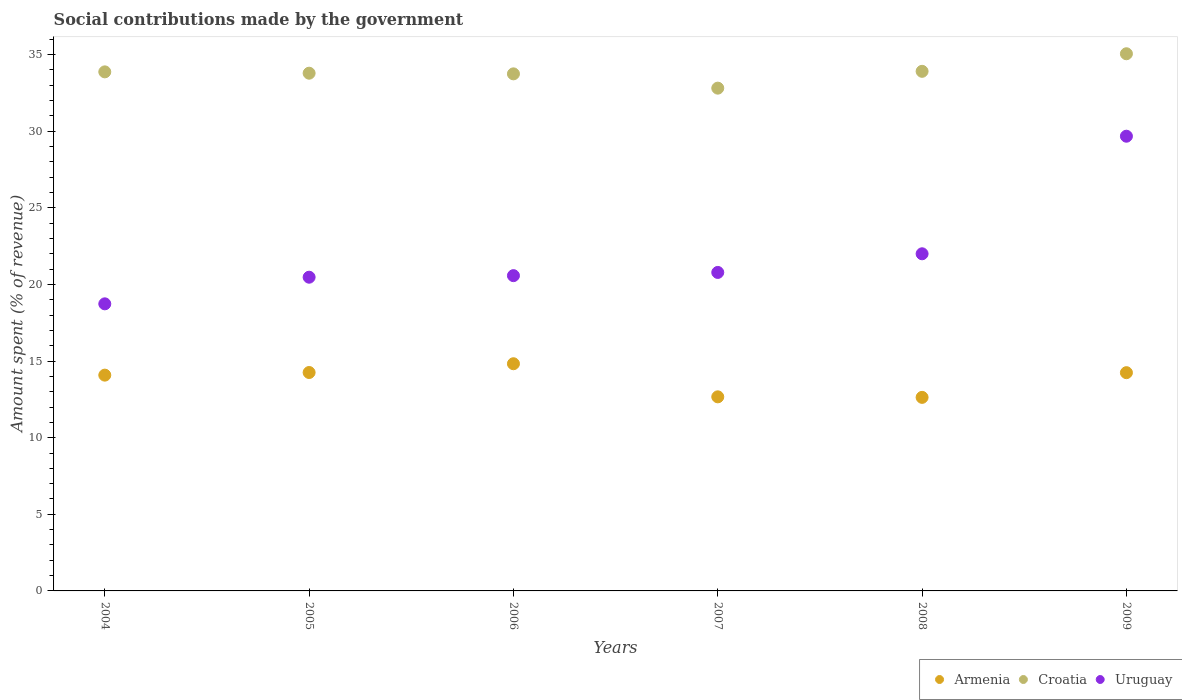How many different coloured dotlines are there?
Provide a succinct answer. 3. Is the number of dotlines equal to the number of legend labels?
Offer a terse response. Yes. What is the amount spent (in %) on social contributions in Armenia in 2007?
Keep it short and to the point. 12.67. Across all years, what is the maximum amount spent (in %) on social contributions in Croatia?
Provide a short and direct response. 35.06. Across all years, what is the minimum amount spent (in %) on social contributions in Croatia?
Your answer should be very brief. 32.81. In which year was the amount spent (in %) on social contributions in Armenia maximum?
Your answer should be compact. 2006. What is the total amount spent (in %) on social contributions in Armenia in the graph?
Make the answer very short. 82.7. What is the difference between the amount spent (in %) on social contributions in Croatia in 2004 and that in 2005?
Your response must be concise. 0.09. What is the difference between the amount spent (in %) on social contributions in Uruguay in 2004 and the amount spent (in %) on social contributions in Armenia in 2009?
Your answer should be compact. 4.49. What is the average amount spent (in %) on social contributions in Croatia per year?
Your response must be concise. 33.86. In the year 2004, what is the difference between the amount spent (in %) on social contributions in Armenia and amount spent (in %) on social contributions in Croatia?
Your answer should be compact. -19.79. What is the ratio of the amount spent (in %) on social contributions in Croatia in 2005 to that in 2008?
Keep it short and to the point. 1. What is the difference between the highest and the second highest amount spent (in %) on social contributions in Armenia?
Your response must be concise. 0.57. What is the difference between the highest and the lowest amount spent (in %) on social contributions in Croatia?
Make the answer very short. 2.24. In how many years, is the amount spent (in %) on social contributions in Croatia greater than the average amount spent (in %) on social contributions in Croatia taken over all years?
Provide a succinct answer. 3. Does the amount spent (in %) on social contributions in Uruguay monotonically increase over the years?
Provide a succinct answer. Yes. Is the amount spent (in %) on social contributions in Armenia strictly less than the amount spent (in %) on social contributions in Croatia over the years?
Ensure brevity in your answer.  Yes. How many dotlines are there?
Give a very brief answer. 3. Are the values on the major ticks of Y-axis written in scientific E-notation?
Provide a succinct answer. No. Does the graph contain any zero values?
Provide a short and direct response. No. Where does the legend appear in the graph?
Provide a short and direct response. Bottom right. How are the legend labels stacked?
Ensure brevity in your answer.  Horizontal. What is the title of the graph?
Provide a short and direct response. Social contributions made by the government. Does "Morocco" appear as one of the legend labels in the graph?
Your answer should be very brief. No. What is the label or title of the X-axis?
Give a very brief answer. Years. What is the label or title of the Y-axis?
Provide a short and direct response. Amount spent (% of revenue). What is the Amount spent (% of revenue) in Armenia in 2004?
Your response must be concise. 14.08. What is the Amount spent (% of revenue) in Croatia in 2004?
Keep it short and to the point. 33.87. What is the Amount spent (% of revenue) in Uruguay in 2004?
Ensure brevity in your answer.  18.74. What is the Amount spent (% of revenue) of Armenia in 2005?
Make the answer very short. 14.25. What is the Amount spent (% of revenue) of Croatia in 2005?
Provide a short and direct response. 33.79. What is the Amount spent (% of revenue) of Uruguay in 2005?
Offer a very short reply. 20.47. What is the Amount spent (% of revenue) in Armenia in 2006?
Offer a terse response. 14.83. What is the Amount spent (% of revenue) of Croatia in 2006?
Provide a short and direct response. 33.74. What is the Amount spent (% of revenue) of Uruguay in 2006?
Keep it short and to the point. 20.58. What is the Amount spent (% of revenue) of Armenia in 2007?
Ensure brevity in your answer.  12.67. What is the Amount spent (% of revenue) of Croatia in 2007?
Ensure brevity in your answer.  32.81. What is the Amount spent (% of revenue) of Uruguay in 2007?
Offer a very short reply. 20.79. What is the Amount spent (% of revenue) in Armenia in 2008?
Your response must be concise. 12.63. What is the Amount spent (% of revenue) in Croatia in 2008?
Offer a terse response. 33.91. What is the Amount spent (% of revenue) in Uruguay in 2008?
Your answer should be very brief. 22. What is the Amount spent (% of revenue) of Armenia in 2009?
Your response must be concise. 14.24. What is the Amount spent (% of revenue) in Croatia in 2009?
Provide a short and direct response. 35.06. What is the Amount spent (% of revenue) in Uruguay in 2009?
Provide a succinct answer. 29.68. Across all years, what is the maximum Amount spent (% of revenue) of Armenia?
Offer a very short reply. 14.83. Across all years, what is the maximum Amount spent (% of revenue) of Croatia?
Provide a short and direct response. 35.06. Across all years, what is the maximum Amount spent (% of revenue) in Uruguay?
Make the answer very short. 29.68. Across all years, what is the minimum Amount spent (% of revenue) of Armenia?
Your answer should be very brief. 12.63. Across all years, what is the minimum Amount spent (% of revenue) of Croatia?
Keep it short and to the point. 32.81. Across all years, what is the minimum Amount spent (% of revenue) in Uruguay?
Provide a succinct answer. 18.74. What is the total Amount spent (% of revenue) of Armenia in the graph?
Provide a short and direct response. 82.7. What is the total Amount spent (% of revenue) of Croatia in the graph?
Give a very brief answer. 203.18. What is the total Amount spent (% of revenue) of Uruguay in the graph?
Offer a terse response. 132.25. What is the difference between the Amount spent (% of revenue) in Armenia in 2004 and that in 2005?
Give a very brief answer. -0.17. What is the difference between the Amount spent (% of revenue) of Croatia in 2004 and that in 2005?
Make the answer very short. 0.09. What is the difference between the Amount spent (% of revenue) in Uruguay in 2004 and that in 2005?
Give a very brief answer. -1.74. What is the difference between the Amount spent (% of revenue) in Armenia in 2004 and that in 2006?
Offer a terse response. -0.74. What is the difference between the Amount spent (% of revenue) of Croatia in 2004 and that in 2006?
Make the answer very short. 0.13. What is the difference between the Amount spent (% of revenue) in Uruguay in 2004 and that in 2006?
Offer a terse response. -1.84. What is the difference between the Amount spent (% of revenue) of Armenia in 2004 and that in 2007?
Make the answer very short. 1.42. What is the difference between the Amount spent (% of revenue) of Croatia in 2004 and that in 2007?
Offer a very short reply. 1.06. What is the difference between the Amount spent (% of revenue) of Uruguay in 2004 and that in 2007?
Offer a terse response. -2.05. What is the difference between the Amount spent (% of revenue) in Armenia in 2004 and that in 2008?
Provide a short and direct response. 1.45. What is the difference between the Amount spent (% of revenue) of Croatia in 2004 and that in 2008?
Offer a very short reply. -0.03. What is the difference between the Amount spent (% of revenue) of Uruguay in 2004 and that in 2008?
Offer a very short reply. -3.27. What is the difference between the Amount spent (% of revenue) in Armenia in 2004 and that in 2009?
Make the answer very short. -0.16. What is the difference between the Amount spent (% of revenue) in Croatia in 2004 and that in 2009?
Your answer should be compact. -1.18. What is the difference between the Amount spent (% of revenue) of Uruguay in 2004 and that in 2009?
Offer a terse response. -10.94. What is the difference between the Amount spent (% of revenue) of Armenia in 2005 and that in 2006?
Your answer should be compact. -0.57. What is the difference between the Amount spent (% of revenue) in Croatia in 2005 and that in 2006?
Provide a short and direct response. 0.04. What is the difference between the Amount spent (% of revenue) in Uruguay in 2005 and that in 2006?
Your answer should be compact. -0.1. What is the difference between the Amount spent (% of revenue) of Armenia in 2005 and that in 2007?
Provide a succinct answer. 1.59. What is the difference between the Amount spent (% of revenue) of Croatia in 2005 and that in 2007?
Make the answer very short. 0.98. What is the difference between the Amount spent (% of revenue) of Uruguay in 2005 and that in 2007?
Keep it short and to the point. -0.31. What is the difference between the Amount spent (% of revenue) of Armenia in 2005 and that in 2008?
Provide a short and direct response. 1.62. What is the difference between the Amount spent (% of revenue) in Croatia in 2005 and that in 2008?
Your response must be concise. -0.12. What is the difference between the Amount spent (% of revenue) in Uruguay in 2005 and that in 2008?
Your response must be concise. -1.53. What is the difference between the Amount spent (% of revenue) of Armenia in 2005 and that in 2009?
Your answer should be compact. 0.01. What is the difference between the Amount spent (% of revenue) in Croatia in 2005 and that in 2009?
Keep it short and to the point. -1.27. What is the difference between the Amount spent (% of revenue) of Uruguay in 2005 and that in 2009?
Your answer should be compact. -9.2. What is the difference between the Amount spent (% of revenue) of Armenia in 2006 and that in 2007?
Your response must be concise. 2.16. What is the difference between the Amount spent (% of revenue) in Croatia in 2006 and that in 2007?
Offer a very short reply. 0.93. What is the difference between the Amount spent (% of revenue) of Uruguay in 2006 and that in 2007?
Your answer should be very brief. -0.21. What is the difference between the Amount spent (% of revenue) in Armenia in 2006 and that in 2008?
Give a very brief answer. 2.19. What is the difference between the Amount spent (% of revenue) of Croatia in 2006 and that in 2008?
Provide a short and direct response. -0.17. What is the difference between the Amount spent (% of revenue) of Uruguay in 2006 and that in 2008?
Your response must be concise. -1.43. What is the difference between the Amount spent (% of revenue) of Armenia in 2006 and that in 2009?
Offer a very short reply. 0.58. What is the difference between the Amount spent (% of revenue) of Croatia in 2006 and that in 2009?
Offer a terse response. -1.31. What is the difference between the Amount spent (% of revenue) of Armenia in 2007 and that in 2008?
Provide a short and direct response. 0.04. What is the difference between the Amount spent (% of revenue) of Croatia in 2007 and that in 2008?
Make the answer very short. -1.1. What is the difference between the Amount spent (% of revenue) in Uruguay in 2007 and that in 2008?
Provide a succinct answer. -1.22. What is the difference between the Amount spent (% of revenue) of Armenia in 2007 and that in 2009?
Offer a very short reply. -1.58. What is the difference between the Amount spent (% of revenue) of Croatia in 2007 and that in 2009?
Your response must be concise. -2.24. What is the difference between the Amount spent (% of revenue) of Uruguay in 2007 and that in 2009?
Ensure brevity in your answer.  -8.89. What is the difference between the Amount spent (% of revenue) in Armenia in 2008 and that in 2009?
Make the answer very short. -1.61. What is the difference between the Amount spent (% of revenue) in Croatia in 2008 and that in 2009?
Make the answer very short. -1.15. What is the difference between the Amount spent (% of revenue) of Uruguay in 2008 and that in 2009?
Provide a short and direct response. -7.67. What is the difference between the Amount spent (% of revenue) of Armenia in 2004 and the Amount spent (% of revenue) of Croatia in 2005?
Provide a short and direct response. -19.7. What is the difference between the Amount spent (% of revenue) in Armenia in 2004 and the Amount spent (% of revenue) in Uruguay in 2005?
Keep it short and to the point. -6.39. What is the difference between the Amount spent (% of revenue) of Croatia in 2004 and the Amount spent (% of revenue) of Uruguay in 2005?
Your answer should be very brief. 13.4. What is the difference between the Amount spent (% of revenue) of Armenia in 2004 and the Amount spent (% of revenue) of Croatia in 2006?
Provide a short and direct response. -19.66. What is the difference between the Amount spent (% of revenue) of Armenia in 2004 and the Amount spent (% of revenue) of Uruguay in 2006?
Offer a very short reply. -6.49. What is the difference between the Amount spent (% of revenue) in Croatia in 2004 and the Amount spent (% of revenue) in Uruguay in 2006?
Offer a very short reply. 13.3. What is the difference between the Amount spent (% of revenue) in Armenia in 2004 and the Amount spent (% of revenue) in Croatia in 2007?
Provide a succinct answer. -18.73. What is the difference between the Amount spent (% of revenue) in Armenia in 2004 and the Amount spent (% of revenue) in Uruguay in 2007?
Your answer should be very brief. -6.7. What is the difference between the Amount spent (% of revenue) in Croatia in 2004 and the Amount spent (% of revenue) in Uruguay in 2007?
Keep it short and to the point. 13.09. What is the difference between the Amount spent (% of revenue) of Armenia in 2004 and the Amount spent (% of revenue) of Croatia in 2008?
Your response must be concise. -19.83. What is the difference between the Amount spent (% of revenue) in Armenia in 2004 and the Amount spent (% of revenue) in Uruguay in 2008?
Provide a succinct answer. -7.92. What is the difference between the Amount spent (% of revenue) in Croatia in 2004 and the Amount spent (% of revenue) in Uruguay in 2008?
Make the answer very short. 11.87. What is the difference between the Amount spent (% of revenue) in Armenia in 2004 and the Amount spent (% of revenue) in Croatia in 2009?
Offer a terse response. -20.97. What is the difference between the Amount spent (% of revenue) of Armenia in 2004 and the Amount spent (% of revenue) of Uruguay in 2009?
Offer a very short reply. -15.59. What is the difference between the Amount spent (% of revenue) of Croatia in 2004 and the Amount spent (% of revenue) of Uruguay in 2009?
Make the answer very short. 4.2. What is the difference between the Amount spent (% of revenue) of Armenia in 2005 and the Amount spent (% of revenue) of Croatia in 2006?
Keep it short and to the point. -19.49. What is the difference between the Amount spent (% of revenue) of Armenia in 2005 and the Amount spent (% of revenue) of Uruguay in 2006?
Ensure brevity in your answer.  -6.32. What is the difference between the Amount spent (% of revenue) in Croatia in 2005 and the Amount spent (% of revenue) in Uruguay in 2006?
Offer a very short reply. 13.21. What is the difference between the Amount spent (% of revenue) of Armenia in 2005 and the Amount spent (% of revenue) of Croatia in 2007?
Make the answer very short. -18.56. What is the difference between the Amount spent (% of revenue) of Armenia in 2005 and the Amount spent (% of revenue) of Uruguay in 2007?
Give a very brief answer. -6.53. What is the difference between the Amount spent (% of revenue) in Croatia in 2005 and the Amount spent (% of revenue) in Uruguay in 2007?
Make the answer very short. 13. What is the difference between the Amount spent (% of revenue) of Armenia in 2005 and the Amount spent (% of revenue) of Croatia in 2008?
Provide a succinct answer. -19.66. What is the difference between the Amount spent (% of revenue) of Armenia in 2005 and the Amount spent (% of revenue) of Uruguay in 2008?
Offer a very short reply. -7.75. What is the difference between the Amount spent (% of revenue) of Croatia in 2005 and the Amount spent (% of revenue) of Uruguay in 2008?
Offer a very short reply. 11.79. What is the difference between the Amount spent (% of revenue) of Armenia in 2005 and the Amount spent (% of revenue) of Croatia in 2009?
Your answer should be compact. -20.8. What is the difference between the Amount spent (% of revenue) of Armenia in 2005 and the Amount spent (% of revenue) of Uruguay in 2009?
Your response must be concise. -15.42. What is the difference between the Amount spent (% of revenue) of Croatia in 2005 and the Amount spent (% of revenue) of Uruguay in 2009?
Give a very brief answer. 4.11. What is the difference between the Amount spent (% of revenue) in Armenia in 2006 and the Amount spent (% of revenue) in Croatia in 2007?
Offer a very short reply. -17.99. What is the difference between the Amount spent (% of revenue) of Armenia in 2006 and the Amount spent (% of revenue) of Uruguay in 2007?
Your answer should be very brief. -5.96. What is the difference between the Amount spent (% of revenue) of Croatia in 2006 and the Amount spent (% of revenue) of Uruguay in 2007?
Ensure brevity in your answer.  12.96. What is the difference between the Amount spent (% of revenue) of Armenia in 2006 and the Amount spent (% of revenue) of Croatia in 2008?
Give a very brief answer. -19.08. What is the difference between the Amount spent (% of revenue) of Armenia in 2006 and the Amount spent (% of revenue) of Uruguay in 2008?
Offer a very short reply. -7.18. What is the difference between the Amount spent (% of revenue) in Croatia in 2006 and the Amount spent (% of revenue) in Uruguay in 2008?
Keep it short and to the point. 11.74. What is the difference between the Amount spent (% of revenue) of Armenia in 2006 and the Amount spent (% of revenue) of Croatia in 2009?
Provide a succinct answer. -20.23. What is the difference between the Amount spent (% of revenue) in Armenia in 2006 and the Amount spent (% of revenue) in Uruguay in 2009?
Give a very brief answer. -14.85. What is the difference between the Amount spent (% of revenue) in Croatia in 2006 and the Amount spent (% of revenue) in Uruguay in 2009?
Make the answer very short. 4.07. What is the difference between the Amount spent (% of revenue) of Armenia in 2007 and the Amount spent (% of revenue) of Croatia in 2008?
Your answer should be very brief. -21.24. What is the difference between the Amount spent (% of revenue) of Armenia in 2007 and the Amount spent (% of revenue) of Uruguay in 2008?
Offer a terse response. -9.34. What is the difference between the Amount spent (% of revenue) of Croatia in 2007 and the Amount spent (% of revenue) of Uruguay in 2008?
Provide a succinct answer. 10.81. What is the difference between the Amount spent (% of revenue) of Armenia in 2007 and the Amount spent (% of revenue) of Croatia in 2009?
Your answer should be compact. -22.39. What is the difference between the Amount spent (% of revenue) of Armenia in 2007 and the Amount spent (% of revenue) of Uruguay in 2009?
Ensure brevity in your answer.  -17.01. What is the difference between the Amount spent (% of revenue) in Croatia in 2007 and the Amount spent (% of revenue) in Uruguay in 2009?
Your response must be concise. 3.14. What is the difference between the Amount spent (% of revenue) in Armenia in 2008 and the Amount spent (% of revenue) in Croatia in 2009?
Give a very brief answer. -22.42. What is the difference between the Amount spent (% of revenue) of Armenia in 2008 and the Amount spent (% of revenue) of Uruguay in 2009?
Your answer should be compact. -17.04. What is the difference between the Amount spent (% of revenue) in Croatia in 2008 and the Amount spent (% of revenue) in Uruguay in 2009?
Your answer should be very brief. 4.23. What is the average Amount spent (% of revenue) of Armenia per year?
Your response must be concise. 13.78. What is the average Amount spent (% of revenue) in Croatia per year?
Ensure brevity in your answer.  33.86. What is the average Amount spent (% of revenue) in Uruguay per year?
Make the answer very short. 22.04. In the year 2004, what is the difference between the Amount spent (% of revenue) in Armenia and Amount spent (% of revenue) in Croatia?
Give a very brief answer. -19.79. In the year 2004, what is the difference between the Amount spent (% of revenue) in Armenia and Amount spent (% of revenue) in Uruguay?
Provide a short and direct response. -4.65. In the year 2004, what is the difference between the Amount spent (% of revenue) in Croatia and Amount spent (% of revenue) in Uruguay?
Offer a very short reply. 15.14. In the year 2005, what is the difference between the Amount spent (% of revenue) of Armenia and Amount spent (% of revenue) of Croatia?
Offer a terse response. -19.53. In the year 2005, what is the difference between the Amount spent (% of revenue) of Armenia and Amount spent (% of revenue) of Uruguay?
Keep it short and to the point. -6.22. In the year 2005, what is the difference between the Amount spent (% of revenue) in Croatia and Amount spent (% of revenue) in Uruguay?
Make the answer very short. 13.31. In the year 2006, what is the difference between the Amount spent (% of revenue) in Armenia and Amount spent (% of revenue) in Croatia?
Provide a short and direct response. -18.92. In the year 2006, what is the difference between the Amount spent (% of revenue) in Armenia and Amount spent (% of revenue) in Uruguay?
Your response must be concise. -5.75. In the year 2006, what is the difference between the Amount spent (% of revenue) in Croatia and Amount spent (% of revenue) in Uruguay?
Offer a very short reply. 13.17. In the year 2007, what is the difference between the Amount spent (% of revenue) in Armenia and Amount spent (% of revenue) in Croatia?
Provide a short and direct response. -20.15. In the year 2007, what is the difference between the Amount spent (% of revenue) of Armenia and Amount spent (% of revenue) of Uruguay?
Provide a succinct answer. -8.12. In the year 2007, what is the difference between the Amount spent (% of revenue) in Croatia and Amount spent (% of revenue) in Uruguay?
Make the answer very short. 12.03. In the year 2008, what is the difference between the Amount spent (% of revenue) in Armenia and Amount spent (% of revenue) in Croatia?
Provide a succinct answer. -21.28. In the year 2008, what is the difference between the Amount spent (% of revenue) in Armenia and Amount spent (% of revenue) in Uruguay?
Make the answer very short. -9.37. In the year 2008, what is the difference between the Amount spent (% of revenue) in Croatia and Amount spent (% of revenue) in Uruguay?
Offer a very short reply. 11.91. In the year 2009, what is the difference between the Amount spent (% of revenue) in Armenia and Amount spent (% of revenue) in Croatia?
Provide a succinct answer. -20.81. In the year 2009, what is the difference between the Amount spent (% of revenue) of Armenia and Amount spent (% of revenue) of Uruguay?
Ensure brevity in your answer.  -15.43. In the year 2009, what is the difference between the Amount spent (% of revenue) in Croatia and Amount spent (% of revenue) in Uruguay?
Provide a short and direct response. 5.38. What is the ratio of the Amount spent (% of revenue) in Armenia in 2004 to that in 2005?
Your answer should be compact. 0.99. What is the ratio of the Amount spent (% of revenue) in Uruguay in 2004 to that in 2005?
Your answer should be very brief. 0.92. What is the ratio of the Amount spent (% of revenue) of Armenia in 2004 to that in 2006?
Keep it short and to the point. 0.95. What is the ratio of the Amount spent (% of revenue) of Croatia in 2004 to that in 2006?
Offer a very short reply. 1. What is the ratio of the Amount spent (% of revenue) of Uruguay in 2004 to that in 2006?
Make the answer very short. 0.91. What is the ratio of the Amount spent (% of revenue) in Armenia in 2004 to that in 2007?
Offer a very short reply. 1.11. What is the ratio of the Amount spent (% of revenue) in Croatia in 2004 to that in 2007?
Give a very brief answer. 1.03. What is the ratio of the Amount spent (% of revenue) in Uruguay in 2004 to that in 2007?
Provide a short and direct response. 0.9. What is the ratio of the Amount spent (% of revenue) in Armenia in 2004 to that in 2008?
Provide a short and direct response. 1.11. What is the ratio of the Amount spent (% of revenue) in Uruguay in 2004 to that in 2008?
Your answer should be very brief. 0.85. What is the ratio of the Amount spent (% of revenue) of Armenia in 2004 to that in 2009?
Give a very brief answer. 0.99. What is the ratio of the Amount spent (% of revenue) in Croatia in 2004 to that in 2009?
Your answer should be very brief. 0.97. What is the ratio of the Amount spent (% of revenue) of Uruguay in 2004 to that in 2009?
Make the answer very short. 0.63. What is the ratio of the Amount spent (% of revenue) in Armenia in 2005 to that in 2006?
Offer a very short reply. 0.96. What is the ratio of the Amount spent (% of revenue) of Uruguay in 2005 to that in 2006?
Keep it short and to the point. 0.99. What is the ratio of the Amount spent (% of revenue) in Armenia in 2005 to that in 2007?
Provide a short and direct response. 1.13. What is the ratio of the Amount spent (% of revenue) of Croatia in 2005 to that in 2007?
Offer a terse response. 1.03. What is the ratio of the Amount spent (% of revenue) in Armenia in 2005 to that in 2008?
Provide a succinct answer. 1.13. What is the ratio of the Amount spent (% of revenue) in Uruguay in 2005 to that in 2008?
Your response must be concise. 0.93. What is the ratio of the Amount spent (% of revenue) of Croatia in 2005 to that in 2009?
Offer a very short reply. 0.96. What is the ratio of the Amount spent (% of revenue) of Uruguay in 2005 to that in 2009?
Give a very brief answer. 0.69. What is the ratio of the Amount spent (% of revenue) in Armenia in 2006 to that in 2007?
Your answer should be compact. 1.17. What is the ratio of the Amount spent (% of revenue) in Croatia in 2006 to that in 2007?
Your answer should be compact. 1.03. What is the ratio of the Amount spent (% of revenue) in Armenia in 2006 to that in 2008?
Provide a succinct answer. 1.17. What is the ratio of the Amount spent (% of revenue) in Uruguay in 2006 to that in 2008?
Ensure brevity in your answer.  0.94. What is the ratio of the Amount spent (% of revenue) of Armenia in 2006 to that in 2009?
Your answer should be compact. 1.04. What is the ratio of the Amount spent (% of revenue) of Croatia in 2006 to that in 2009?
Provide a short and direct response. 0.96. What is the ratio of the Amount spent (% of revenue) of Uruguay in 2006 to that in 2009?
Ensure brevity in your answer.  0.69. What is the ratio of the Amount spent (% of revenue) of Armenia in 2007 to that in 2008?
Your response must be concise. 1. What is the ratio of the Amount spent (% of revenue) in Croatia in 2007 to that in 2008?
Your answer should be compact. 0.97. What is the ratio of the Amount spent (% of revenue) in Uruguay in 2007 to that in 2008?
Ensure brevity in your answer.  0.94. What is the ratio of the Amount spent (% of revenue) of Armenia in 2007 to that in 2009?
Offer a very short reply. 0.89. What is the ratio of the Amount spent (% of revenue) in Croatia in 2007 to that in 2009?
Provide a short and direct response. 0.94. What is the ratio of the Amount spent (% of revenue) of Uruguay in 2007 to that in 2009?
Keep it short and to the point. 0.7. What is the ratio of the Amount spent (% of revenue) in Armenia in 2008 to that in 2009?
Keep it short and to the point. 0.89. What is the ratio of the Amount spent (% of revenue) of Croatia in 2008 to that in 2009?
Offer a terse response. 0.97. What is the ratio of the Amount spent (% of revenue) in Uruguay in 2008 to that in 2009?
Your answer should be compact. 0.74. What is the difference between the highest and the second highest Amount spent (% of revenue) of Armenia?
Provide a succinct answer. 0.57. What is the difference between the highest and the second highest Amount spent (% of revenue) in Croatia?
Ensure brevity in your answer.  1.15. What is the difference between the highest and the second highest Amount spent (% of revenue) of Uruguay?
Ensure brevity in your answer.  7.67. What is the difference between the highest and the lowest Amount spent (% of revenue) in Armenia?
Give a very brief answer. 2.19. What is the difference between the highest and the lowest Amount spent (% of revenue) of Croatia?
Your answer should be very brief. 2.24. What is the difference between the highest and the lowest Amount spent (% of revenue) of Uruguay?
Give a very brief answer. 10.94. 